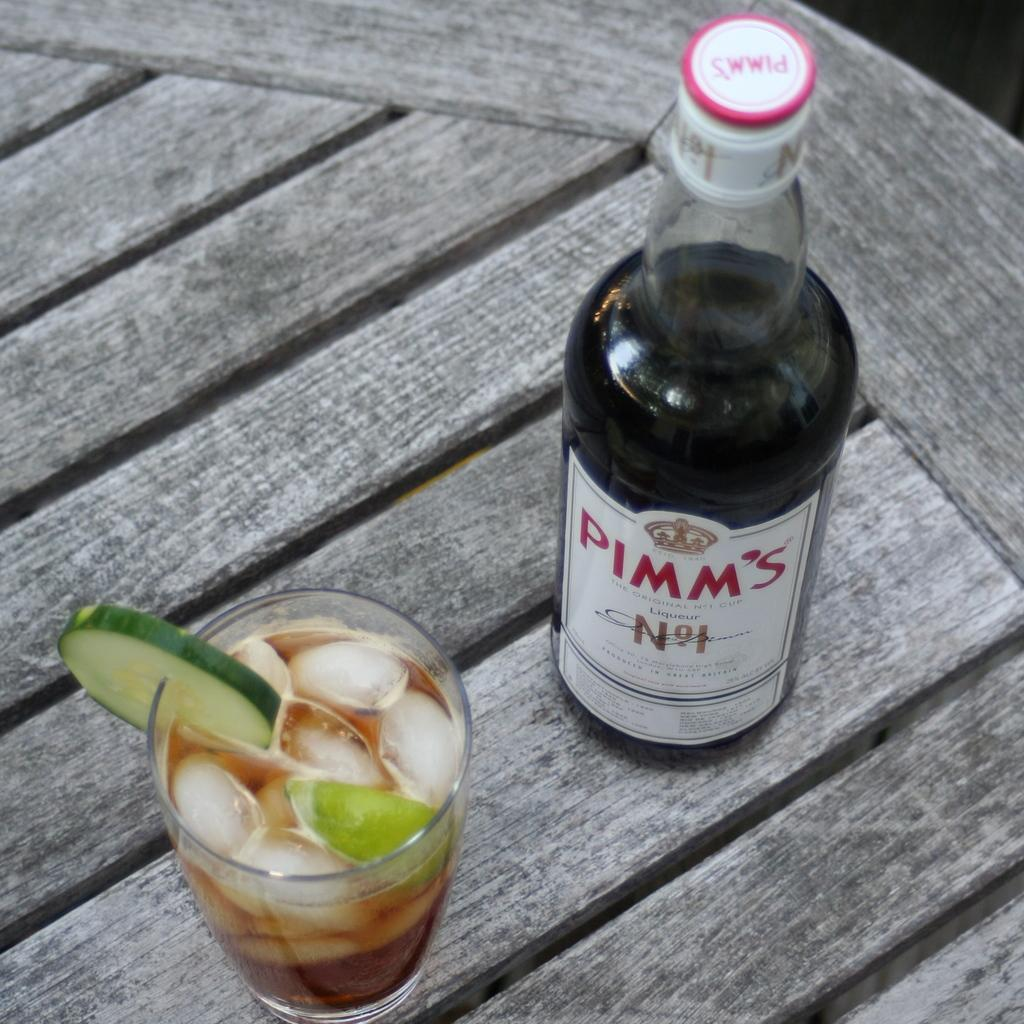What is present in the image that can hold liquids? There is a bottle and a glass in the image. What is inside the glass? The glass contains ice and a vegetable slice. Can you describe the contents of the bottle? The facts provided do not mention the contents of the bottle. Is there a river flowing through the image? No, there is no river present in the image. What type of lace can be seen on the glass in the image? There is no lace present on the glass in the image. 